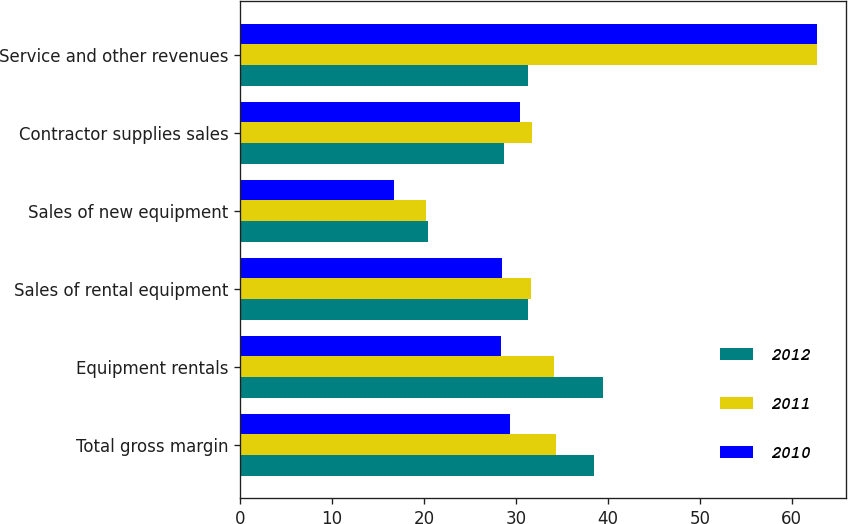Convert chart. <chart><loc_0><loc_0><loc_500><loc_500><stacked_bar_chart><ecel><fcel>Total gross margin<fcel>Equipment rentals<fcel>Sales of rental equipment<fcel>Sales of new equipment<fcel>Contractor supplies sales<fcel>Service and other revenues<nl><fcel>2012<fcel>38.5<fcel>39.5<fcel>31.3<fcel>20.4<fcel>28.7<fcel>31.3<nl><fcel>2011<fcel>34.4<fcel>34.2<fcel>31.7<fcel>20.2<fcel>31.8<fcel>62.7<nl><fcel>2010<fcel>29.4<fcel>28.4<fcel>28.5<fcel>16.7<fcel>30.5<fcel>62.8<nl></chart> 